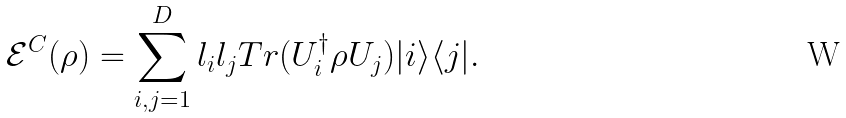Convert formula to latex. <formula><loc_0><loc_0><loc_500><loc_500>\mathcal { E } ^ { C } ( \rho ) = \sum _ { i , j = 1 } ^ { D } l _ { i } l _ { j } T r ( U ^ { \dag } _ { i } \rho U _ { j } ) | i \rangle \langle j | .</formula> 